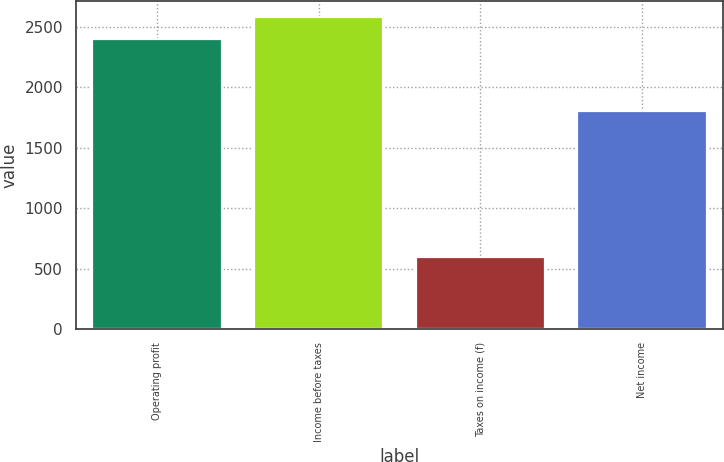Convert chart. <chart><loc_0><loc_0><loc_500><loc_500><bar_chart><fcel>Operating profit<fcel>Income before taxes<fcel>Taxes on income (f)<fcel>Net income<nl><fcel>2402<fcel>2582.3<fcel>599<fcel>1803<nl></chart> 